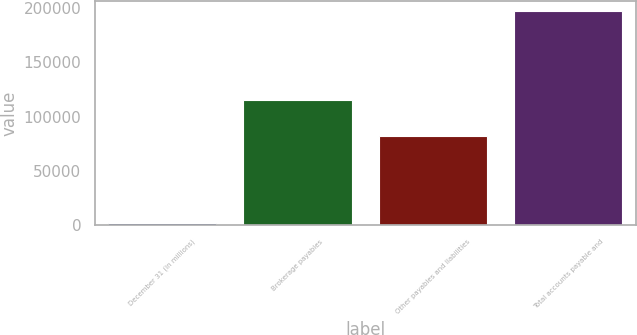Convert chart. <chart><loc_0><loc_0><loc_500><loc_500><bar_chart><fcel>December 31 (in millions)<fcel>Brokerage payables<fcel>Other payables and liabilities<fcel>Total accounts payable and<nl><fcel>2018<fcel>114794<fcel>81916<fcel>196710<nl></chart> 